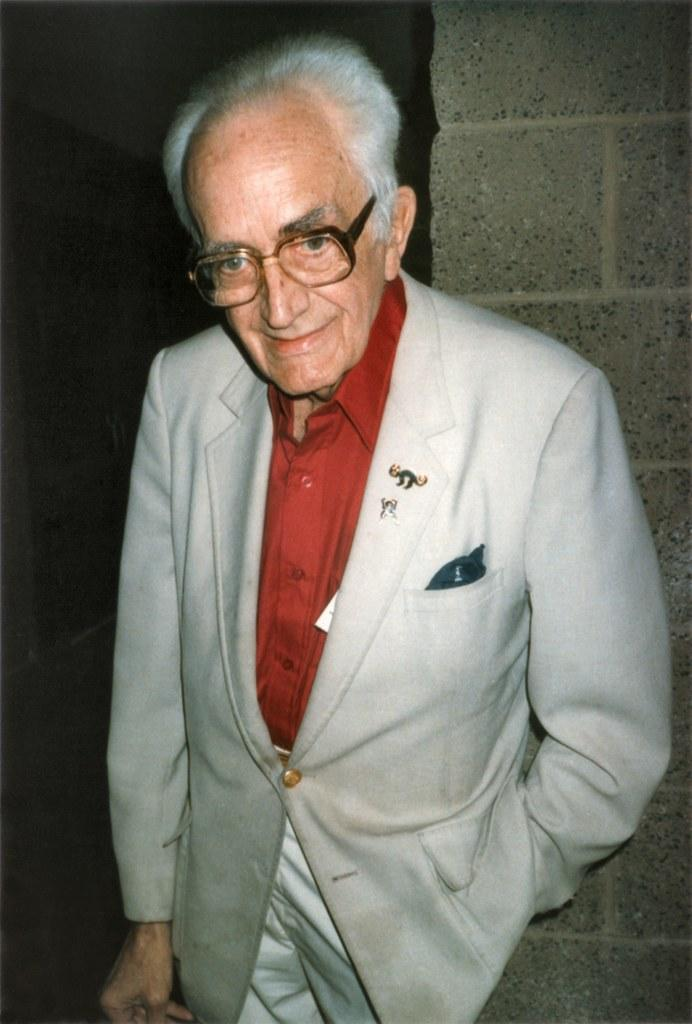Who is present in the image? There is a man in the image. What is the man wearing? The man is wearing a suit. What accessory can be seen on the man's face? The man has spectacles. What can be seen in the background of the image? There is a wall in the background of the image. What type of advertisement can be seen on the cow in the image? There is no cow present in the image, and therefore no advertisement can be seen on it. 